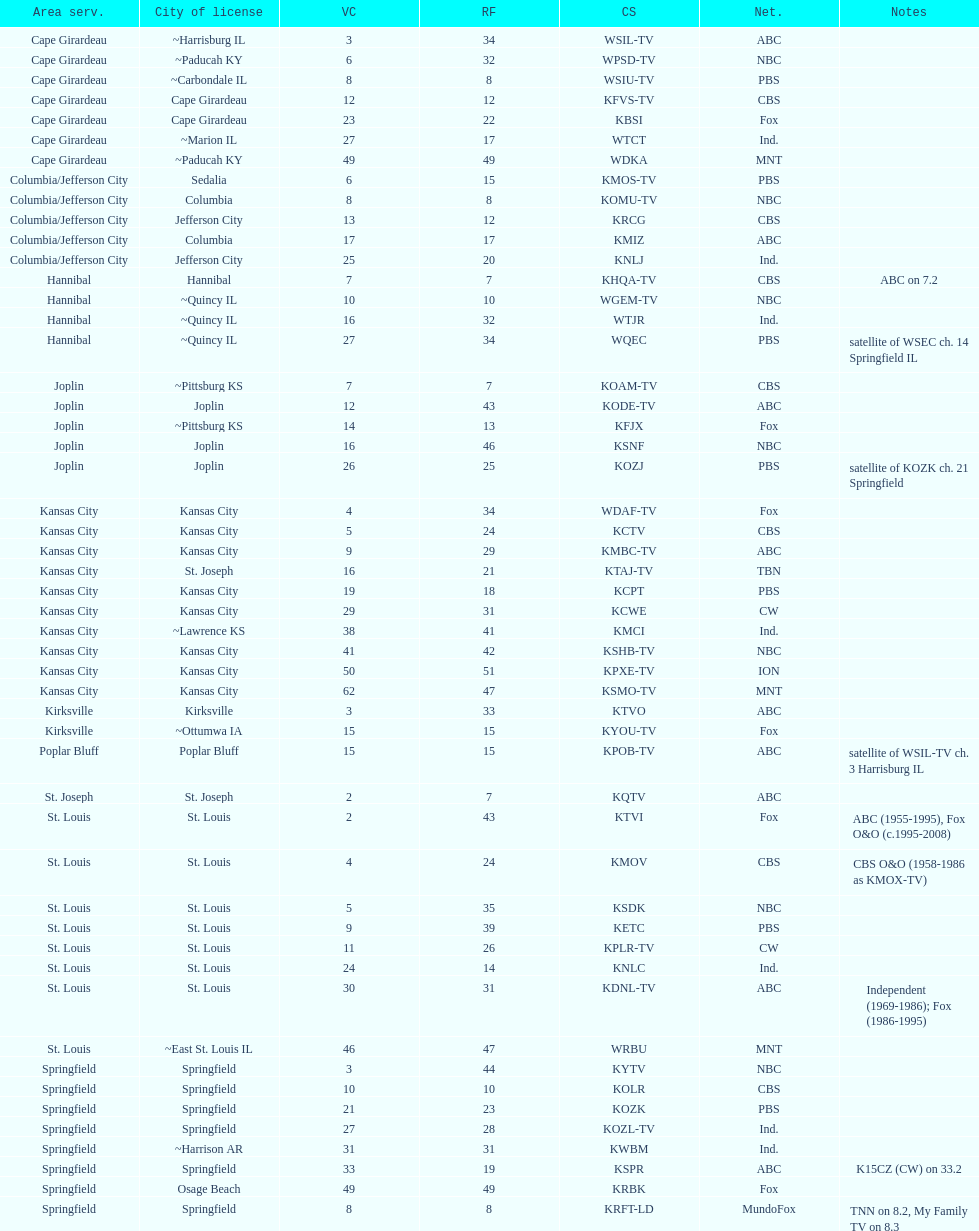What is the total number of stations under the cbs network? 7. 